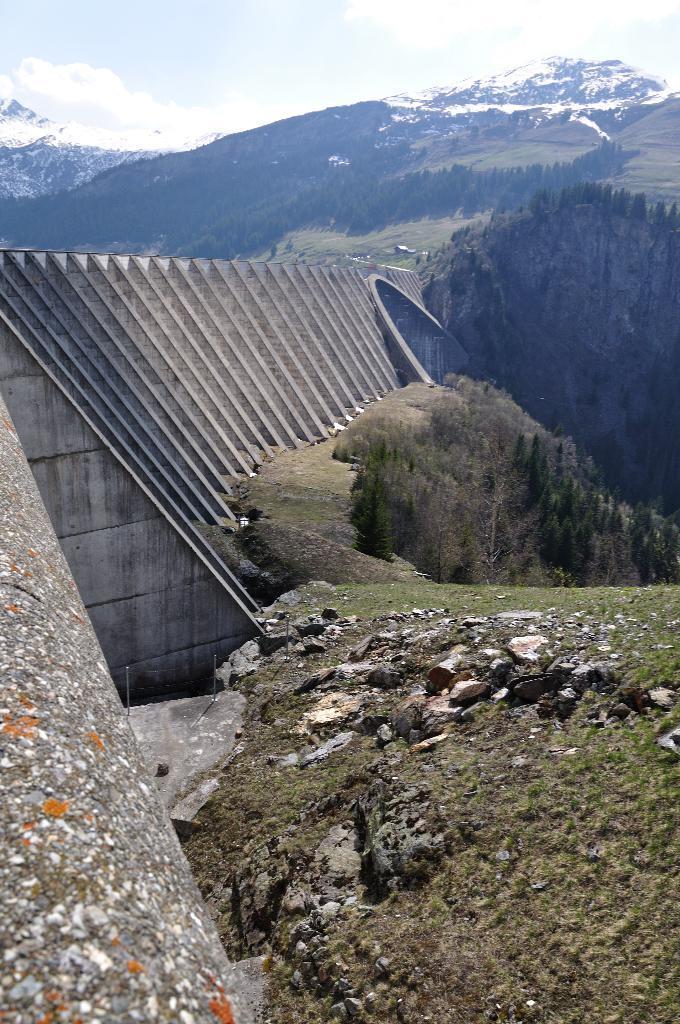Could you give a brief overview of what you see in this image? In the picture we can see some grass surface with some rocks and stones on it and in the besides, we can see some construction which is like a dam and behind it, we can see some hills with trees and mountains with a snow and behind it we can see a sky with clouds. 